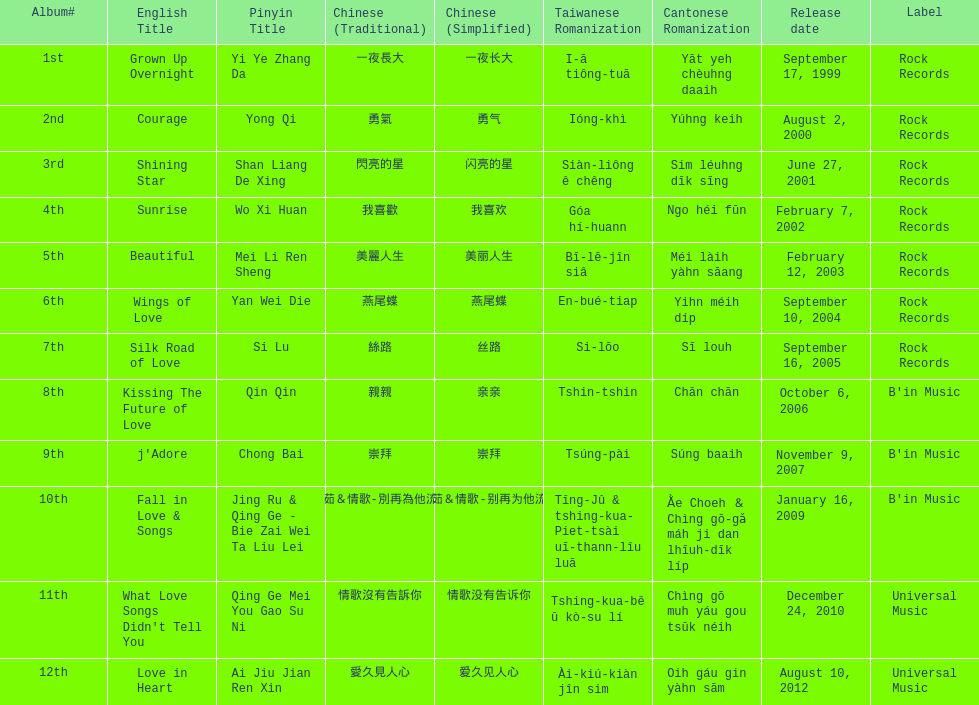Which album was released later, beautiful, or j'adore? J'adore. 